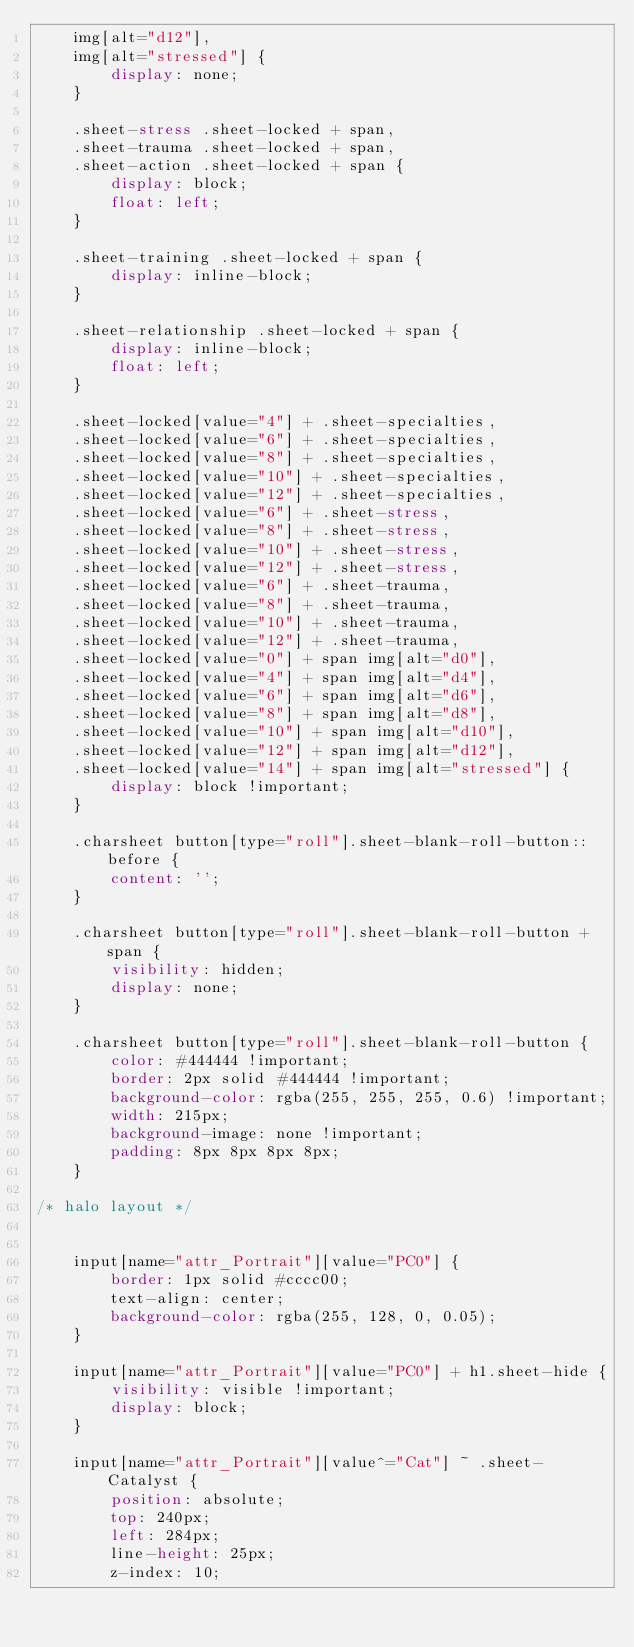Convert code to text. <code><loc_0><loc_0><loc_500><loc_500><_CSS_>	img[alt="d12"],
	img[alt="stressed"] {
		display: none;
	}

	.sheet-stress .sheet-locked + span,
	.sheet-trauma .sheet-locked + span,
	.sheet-action .sheet-locked + span {
		display: block;
		float: left;
	}
	
	.sheet-training .sheet-locked + span {
		display: inline-block;
	}
	
	.sheet-relationship .sheet-locked + span {
		display: inline-block;
		float: left;
	}
	
	.sheet-locked[value="4"] + .sheet-specialties,
	.sheet-locked[value="6"] + .sheet-specialties,
	.sheet-locked[value="8"] + .sheet-specialties,
	.sheet-locked[value="10"] + .sheet-specialties,
	.sheet-locked[value="12"] + .sheet-specialties,
	.sheet-locked[value="6"] + .sheet-stress,
	.sheet-locked[value="8"] + .sheet-stress,
	.sheet-locked[value="10"] + .sheet-stress,
	.sheet-locked[value="12"] + .sheet-stress,
	.sheet-locked[value="6"] + .sheet-trauma,
	.sheet-locked[value="8"] + .sheet-trauma,
	.sheet-locked[value="10"] + .sheet-trauma,
	.sheet-locked[value="12"] + .sheet-trauma,
	.sheet-locked[value="0"] + span img[alt="d0"],
	.sheet-locked[value="4"] + span img[alt="d4"],
	.sheet-locked[value="6"] + span img[alt="d6"],
	.sheet-locked[value="8"] + span img[alt="d8"],
	.sheet-locked[value="10"] + span img[alt="d10"],
	.sheet-locked[value="12"] + span img[alt="d12"],
	.sheet-locked[value="14"] + span img[alt="stressed"] {
		display: block !important;
	}
	
	.charsheet button[type="roll"].sheet-blank-roll-button::before {
		content: '';
	}
	
	.charsheet button[type="roll"].sheet-blank-roll-button + span {
		visibility: hidden;
		display: none;
	}
	
	.charsheet button[type="roll"].sheet-blank-roll-button {
		color: #444444 !important;
		border: 2px solid #444444 !important;
		background-color: rgba(255, 255, 255, 0.6) !important;
		width: 215px;
		background-image: none !important;
		padding: 8px 8px 8px 8px;
	}

/* halo layout */

	
	input[name="attr_Portrait"][value="PC0"] {
		border: 1px solid #cccc00;
		text-align: center;
		background-color: rgba(255, 128, 0, 0.05);
	}

	input[name="attr_Portrait"][value="PC0"] + h1.sheet-hide {
		visibility: visible !important;
		display: block;
	}

	input[name="attr_Portrait"][value^="Cat"] ~ .sheet-Catalyst {
		position: absolute;
		top: 240px;
		left: 284px;
		line-height: 25px;
		z-index: 10;</code> 